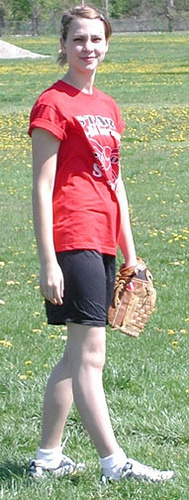Describe the objects in this image and their specific colors. I can see people in gray, white, lightpink, and darkgray tones and baseball glove in gray, tan, and ivory tones in this image. 